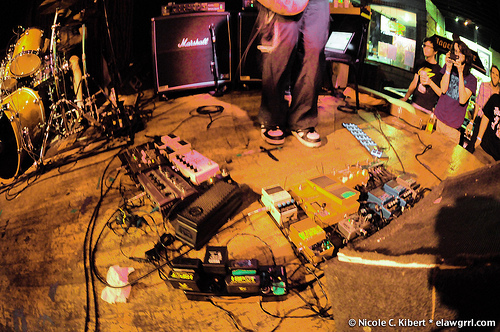<image>
Is there a drum on the stage? Yes. Looking at the image, I can see the drum is positioned on top of the stage, with the stage providing support. 